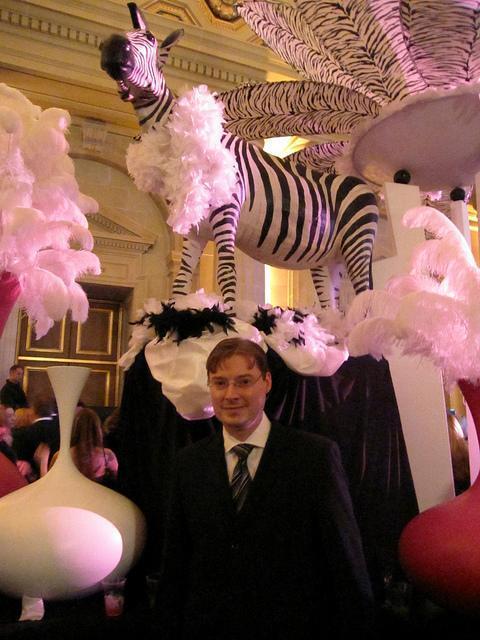How many people are visible?
Give a very brief answer. 2. How many zebras can be seen?
Give a very brief answer. 1. 